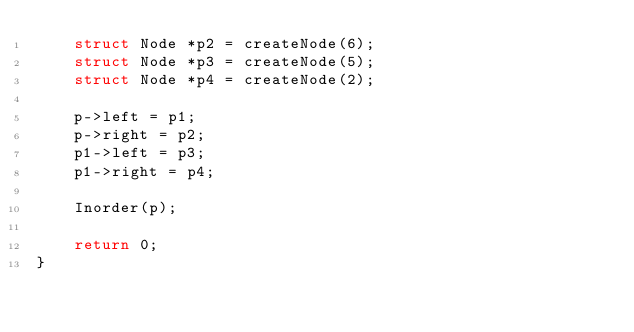<code> <loc_0><loc_0><loc_500><loc_500><_C_>    struct Node *p2 = createNode(6);
    struct Node *p3 = createNode(5);
    struct Node *p4 = createNode(2);

    p->left = p1;
    p->right = p2;
    p1->left = p3;
    p1->right = p4;
    
    Inorder(p); 

    return 0; 
}
</code> 